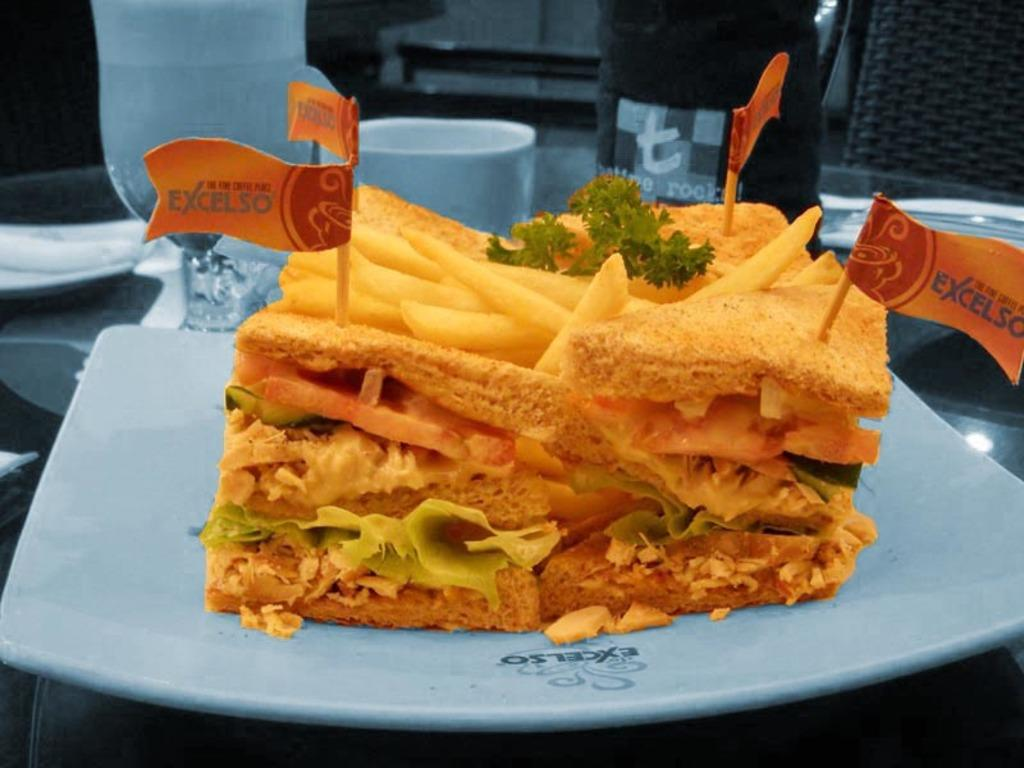What is the main subject in the foreground of the picture? There is a food item in the foreground of the picture, and it is in a plate. What other items can be seen in the background of the picture? In the background of the picture, there is a glass, a cup, another plate, a tissue, and chairs. How many plates are visible in the image? There are two plates visible in the image. What is the man's level of fear in the image? There is no man present in the image, so it is not possible to determine his level of fear. 